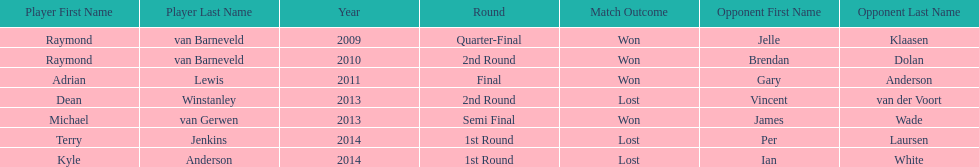Help me parse the entirety of this table. {'header': ['Player First Name', 'Player Last Name', 'Year', 'Round', 'Match Outcome', 'Opponent First Name', 'Opponent Last Name'], 'rows': [['Raymond', 'van Barneveld', '2009', 'Quarter-Final', 'Won', 'Jelle', 'Klaasen'], ['Raymond', 'van Barneveld', '2010', '2nd Round', 'Won', 'Brendan', 'Dolan'], ['Adrian', 'Lewis', '2011', 'Final', 'Won', 'Gary', 'Anderson'], ['Dean', 'Winstanley', '2013', '2nd Round', 'Lost', 'Vincent', 'van der Voort'], ['Michael', 'van Gerwen', '2013', 'Semi Final', 'Won', 'James', 'Wade'], ['Terry', 'Jenkins', '2014', '1st Round', 'Lost', 'Per', 'Laursen'], ['Kyle', 'Anderson', '2014', '1st Round', 'Lost', 'Ian', 'White']]} Is dean winstanley listed above or below kyle anderson? Above. 